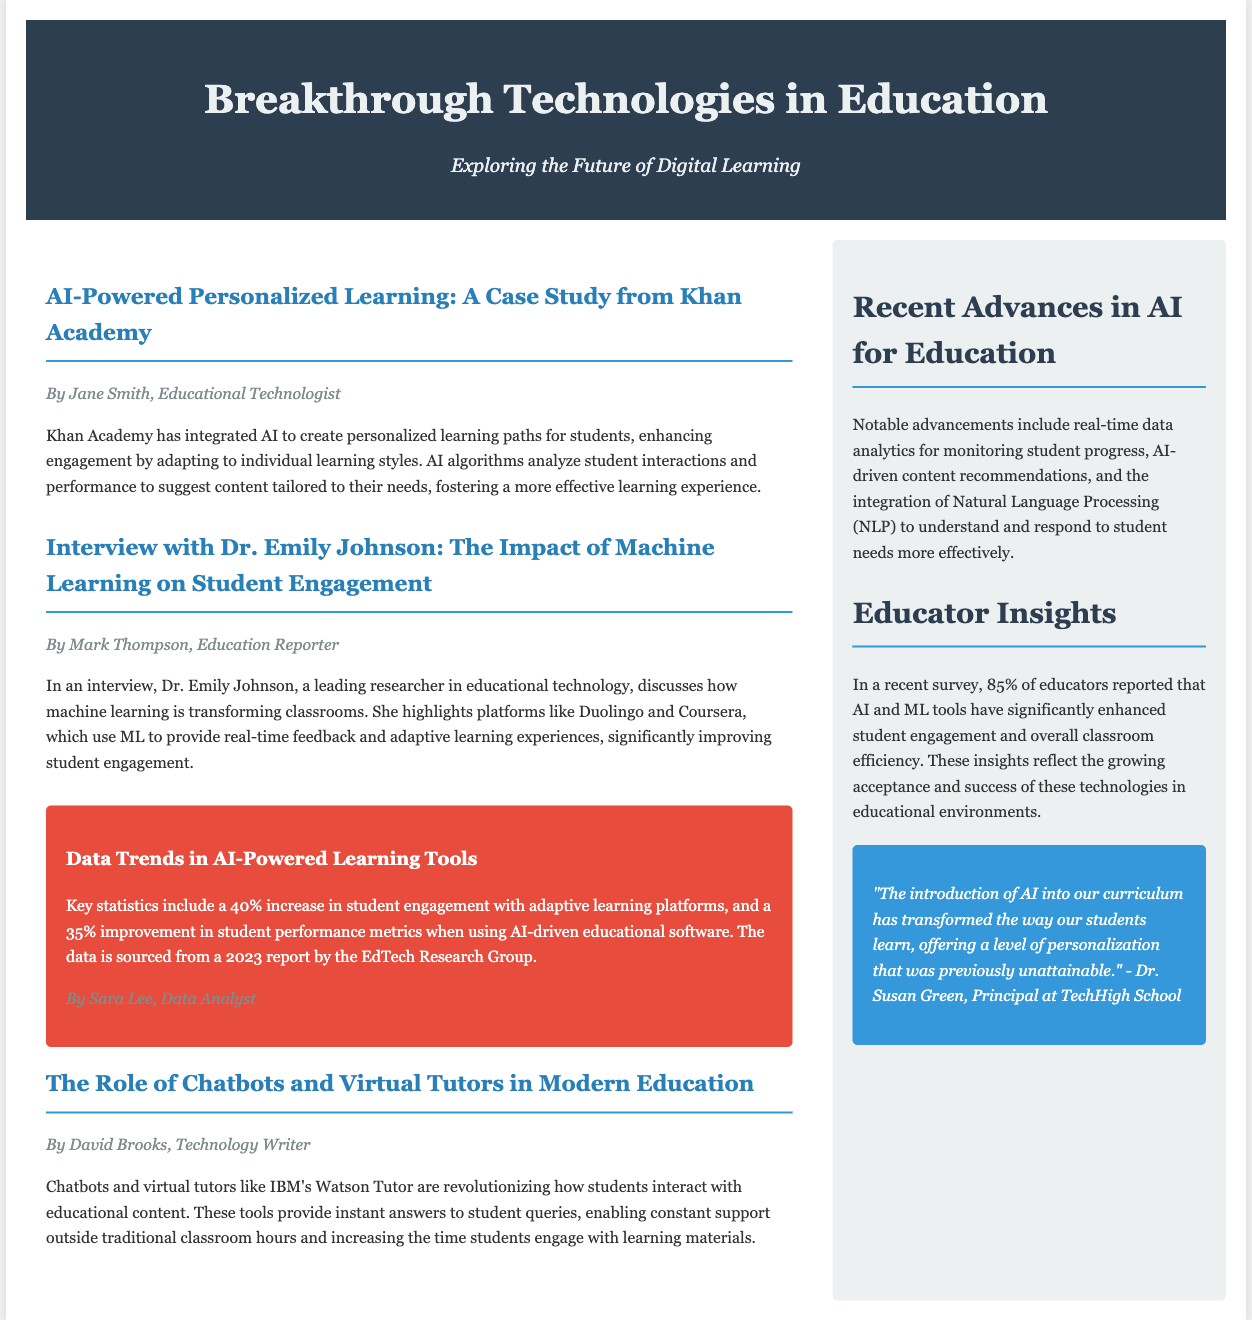what is the title of the article by Jane Smith? The title is explicitly stated in the article, which is "AI-Powered Personalized Learning: A Case Study from Khan Academy."
Answer: AI-Powered Personalized Learning: A Case Study from Khan Academy who conducted the interview about the impact of machine learning? The document mentions that Mark Thompson is the Education Reporter who conducted the interview with Dr. Emily Johnson.
Answer: Mark Thompson what percentage of educators reported enhanced student engagement due to AI tools? The document states that 85% of educators reported this enhancement in student engagement.
Answer: 85% which platform is mentioned as utilizing machine learning for adaptive learning experiences? The document highlights Duolingo and Coursera as platforms using machine learning.
Answer: Duolingo and Coursera how much improvement in student performance metrics is noted when using AI-driven software? The document indicates a 35% improvement in student performance metrics.
Answer: 35% what innovative tool does IBM provide for student interaction with educational content? The document states that IBM's Watson Tutor is the tool discussed for this interaction.
Answer: IBM's Watson Tutor what is the main focus of the sidebar section titled "Recent Advances in AI for Education"? The section discusses notable advancements such as real-time data analytics and AI-driven content recommendations.
Answer: Real-time data analytics and AI-driven content recommendations who is the author of the infographic on data trends? The author mentioned for the infographic is Sara Lee, identified as a Data Analyst.
Answer: Sara Lee 